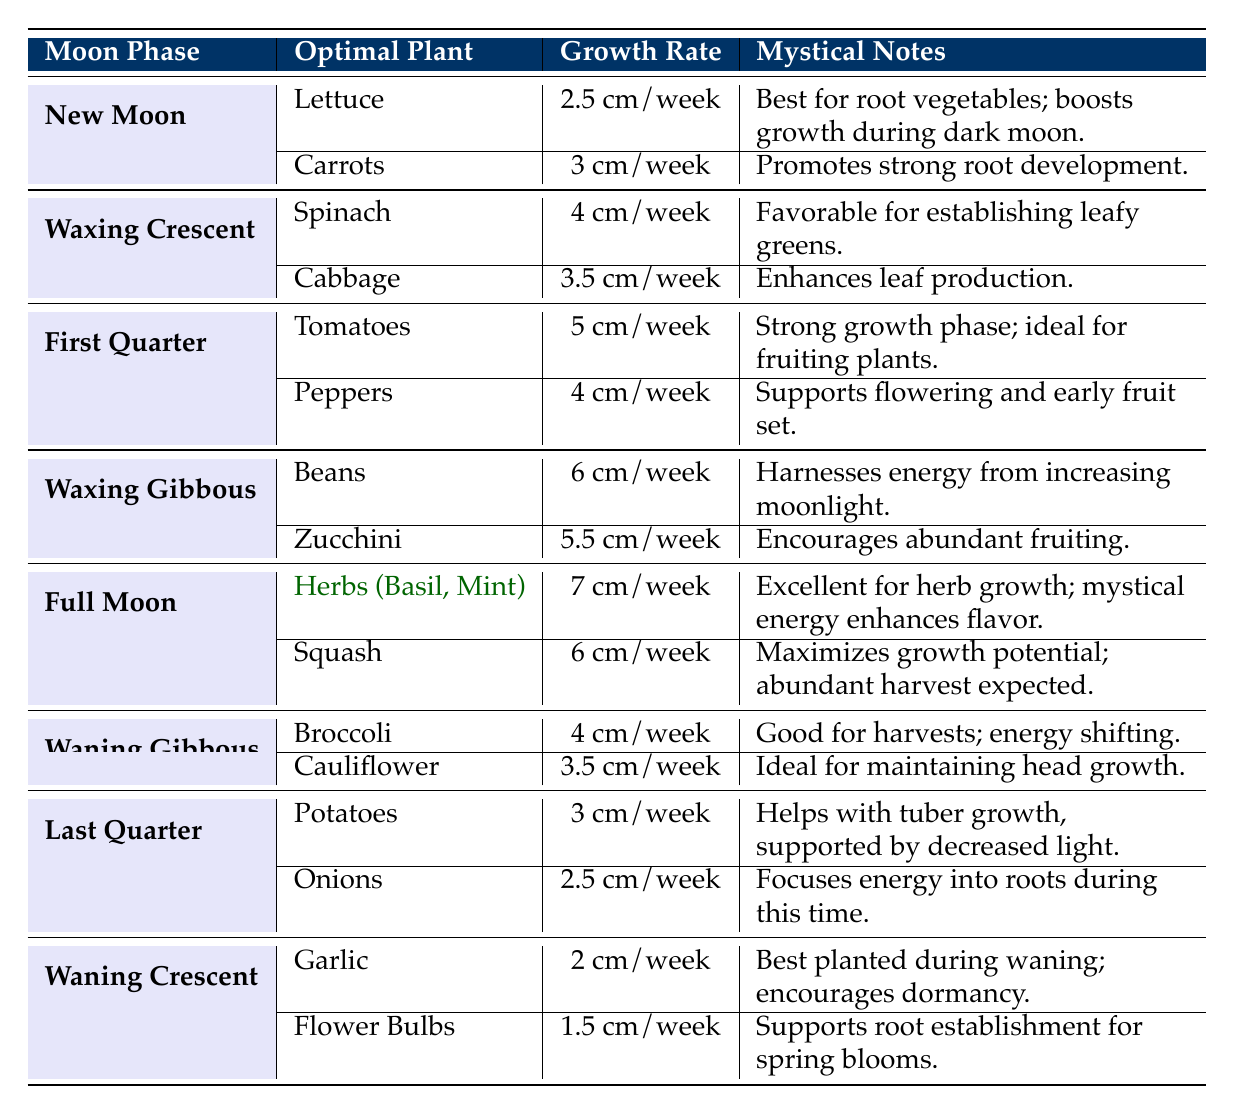What is the growth rate of lettuce during the New Moon phase? The table indicates that lettuce has a growth rate of 2.5 cm/week during the New Moon phase.
Answer: 2.5 cm/week Which plant grows the fastest during the Full Moon phase? According to the table, herbs (Basil, Mint) have the highest growth rate of 7 cm/week during the Full Moon phase, making them the fastest growing plant in that phase.
Answer: Herbs (Basil, Mint) How much does the growth rate of beans during the Waxing Gibbous phase exceed that of carrots during the New Moon phase? For beans during the Waxing Gibbous phase, the growth rate is 6 cm/week, while for carrots during the New Moon phase, it is 3 cm/week. The difference in growth rates is 6 - 3 = 3 cm/week.
Answer: 3 cm/week Are squash and zucchini both recommended for planting during the Waxing Gibbous phase? The table shows that both squash and zucchini are listed as optimal plants during the Waxing Gibbous phase.
Answer: Yes What is the average growth rate of all plants recommended for the Last Quarter phase? The growth rates for potatoes and onions during the Last Quarter phase are 3 cm/week and 2.5 cm/week, respectively. To find the average, we sum the growth rates: (3 + 2.5) = 5.5, and then divide by the number of plants, which is 2. Thus, the average growth rate is 5.5/2 = 2.75 cm/week.
Answer: 2.75 cm/week Which moon phase is associated with the highest growth rate of plants? The table reveals that the Full Moon phase is associated with the highest growth rate, specifically for herbs (Basil, Mint) at 7 cm/week.
Answer: Full Moon What plant's growth rate is positively affected by increasing moonlight during the Waxing Gibbous phase? The data indicates that beans have a growth rate of 6 cm/week and are positively affected by increasing moonlight during the Waxing Gibbous phase.
Answer: Beans Is garlic best planted during the waning or waxing phases of the moon? The table specifies that garlic is best planted during the waning phase, specifically the Waning Crescent.
Answer: Waning phase 